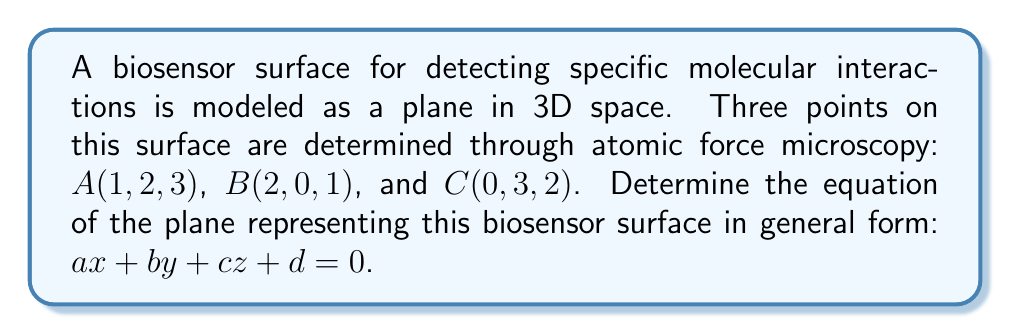Could you help me with this problem? 1) To find the equation of a plane, we need to calculate the normal vector to the plane and a point on the plane.

2) We can find two vectors on the plane:
   $\vec{AB} = B - A = (1, -2, -2)$
   $\vec{AC} = C - A = (-1, 1, -1)$

3) The normal vector $\vec{n}$ is the cross product of these vectors:
   $\vec{n} = \vec{AB} \times \vec{AC}$
   
   $$\vec{n} = \begin{vmatrix}
   i & j & k \\
   1 & -2 & -2 \\
   -1 & 1 & -1
   \end{vmatrix}$$
   
   $\vec{n} = ((-2)(-1) - (-2)(1))i - ((1)(-1) - (-2)(-1))j + ((1)(1) - (-2)(-1))k$
   
   $\vec{n} = (2 - (-2))i - (-1 - 2)j + (1 - 2)k$
   
   $\vec{n} = 4i + 3j - k$

4) So, $a = 4$, $b = 3$, and $c = -1$

5) Using point $A(1, 2, 3)$, we can find $d$:
   $4(1) + 3(2) + (-1)(3) + d = 0$
   $4 + 6 - 3 + d = 0$
   $d = -7$

6) Therefore, the equation of the plane is:
   $4x + 3y - z - 7 = 0$
Answer: $4x + 3y - z - 7 = 0$ 